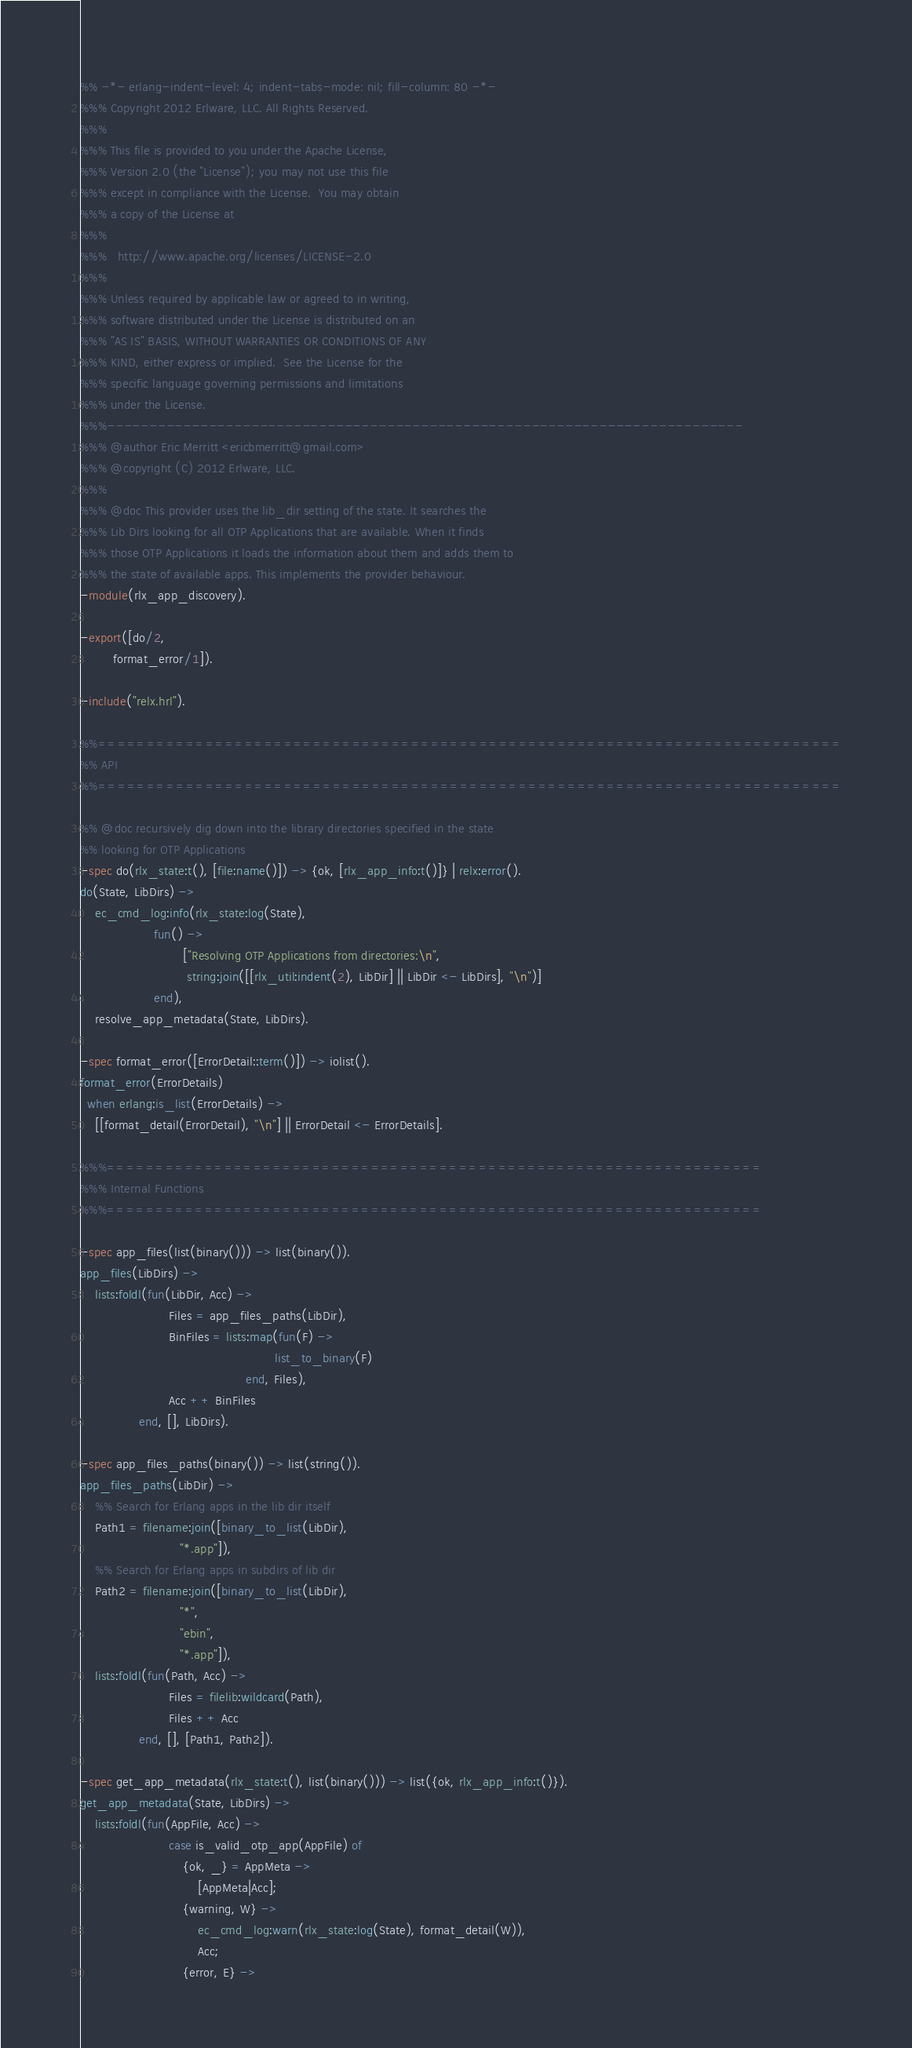Convert code to text. <code><loc_0><loc_0><loc_500><loc_500><_Erlang_>%% -*- erlang-indent-level: 4; indent-tabs-mode: nil; fill-column: 80 -*-
%%% Copyright 2012 Erlware, LLC. All Rights Reserved.
%%%
%%% This file is provided to you under the Apache License,
%%% Version 2.0 (the "License"); you may not use this file
%%% except in compliance with the License.  You may obtain
%%% a copy of the License at
%%%
%%%   http://www.apache.org/licenses/LICENSE-2.0
%%%
%%% Unless required by applicable law or agreed to in writing,
%%% software distributed under the License is distributed on an
%%% "AS IS" BASIS, WITHOUT WARRANTIES OR CONDITIONS OF ANY
%%% KIND, either express or implied.  See the License for the
%%% specific language governing permissions and limitations
%%% under the License.
%%%---------------------------------------------------------------------------
%%% @author Eric Merritt <ericbmerritt@gmail.com>
%%% @copyright (C) 2012 Erlware, LLC.
%%%
%%% @doc This provider uses the lib_dir setting of the state. It searches the
%%% Lib Dirs looking for all OTP Applications that are available. When it finds
%%% those OTP Applications it loads the information about them and adds them to
%%% the state of available apps. This implements the provider behaviour.
-module(rlx_app_discovery).

-export([do/2,
         format_error/1]).

-include("relx.hrl").

%%============================================================================
%% API
%%============================================================================

%% @doc recursively dig down into the library directories specified in the state
%% looking for OTP Applications
-spec do(rlx_state:t(), [file:name()]) -> {ok, [rlx_app_info:t()]} | relx:error().
do(State, LibDirs) ->
    ec_cmd_log:info(rlx_state:log(State),
                    fun() ->
                            ["Resolving OTP Applications from directories:\n",
                             string:join([[rlx_util:indent(2), LibDir] || LibDir <- LibDirs], "\n")]
                    end),
    resolve_app_metadata(State, LibDirs).

-spec format_error([ErrorDetail::term()]) -> iolist().
format_error(ErrorDetails)
  when erlang:is_list(ErrorDetails) ->
    [[format_detail(ErrorDetail), "\n"] || ErrorDetail <- ErrorDetails].

%%%===================================================================
%%% Internal Functions
%%%===================================================================

-spec app_files(list(binary())) -> list(binary()).
app_files(LibDirs) ->
    lists:foldl(fun(LibDir, Acc) ->
                        Files = app_files_paths(LibDir),
                        BinFiles = lists:map(fun(F) ->
                                                     list_to_binary(F)
                                             end, Files),
                        Acc ++ BinFiles
                end, [], LibDirs).

-spec app_files_paths(binary()) -> list(string()).
app_files_paths(LibDir) ->
    %% Search for Erlang apps in the lib dir itself
    Path1 = filename:join([binary_to_list(LibDir),
                           "*.app"]),
    %% Search for Erlang apps in subdirs of lib dir
    Path2 = filename:join([binary_to_list(LibDir),
                           "*",
                           "ebin",
                           "*.app"]),
    lists:foldl(fun(Path, Acc) ->
                        Files = filelib:wildcard(Path),
                        Files ++ Acc
                end, [], [Path1, Path2]).

-spec get_app_metadata(rlx_state:t(), list(binary())) -> list({ok, rlx_app_info:t()}).
get_app_metadata(State, LibDirs) ->
    lists:foldl(fun(AppFile, Acc) ->
                        case is_valid_otp_app(AppFile) of
                            {ok, _} = AppMeta ->
                                [AppMeta|Acc];
                            {warning, W} ->
                                ec_cmd_log:warn(rlx_state:log(State), format_detail(W)),
                                Acc;
                            {error, E} -></code> 